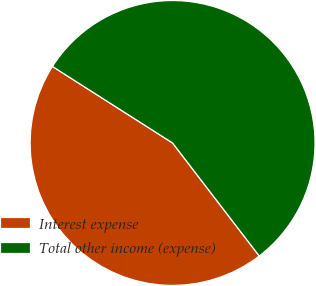Convert chart. <chart><loc_0><loc_0><loc_500><loc_500><pie_chart><fcel>Interest expense<fcel>Total other income (expense)<nl><fcel>44.44%<fcel>55.56%<nl></chart> 